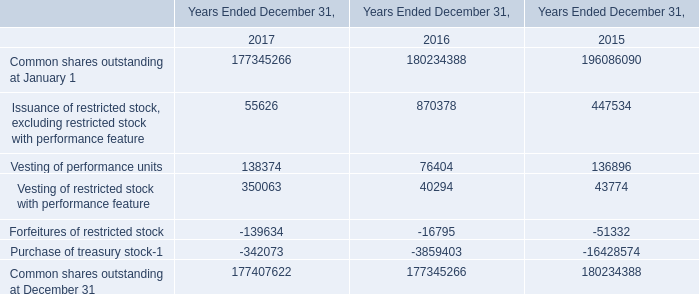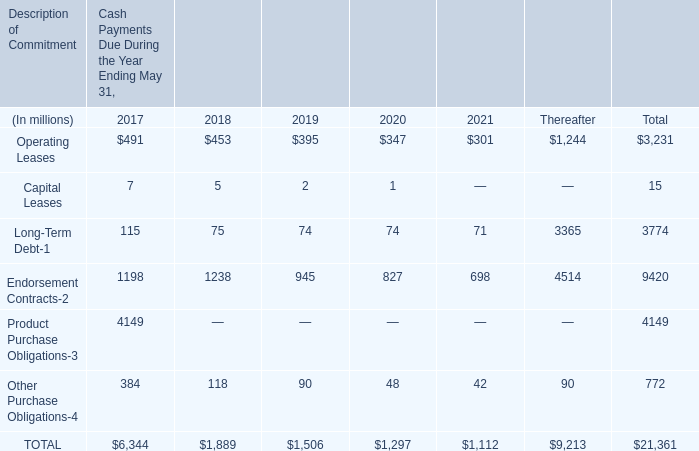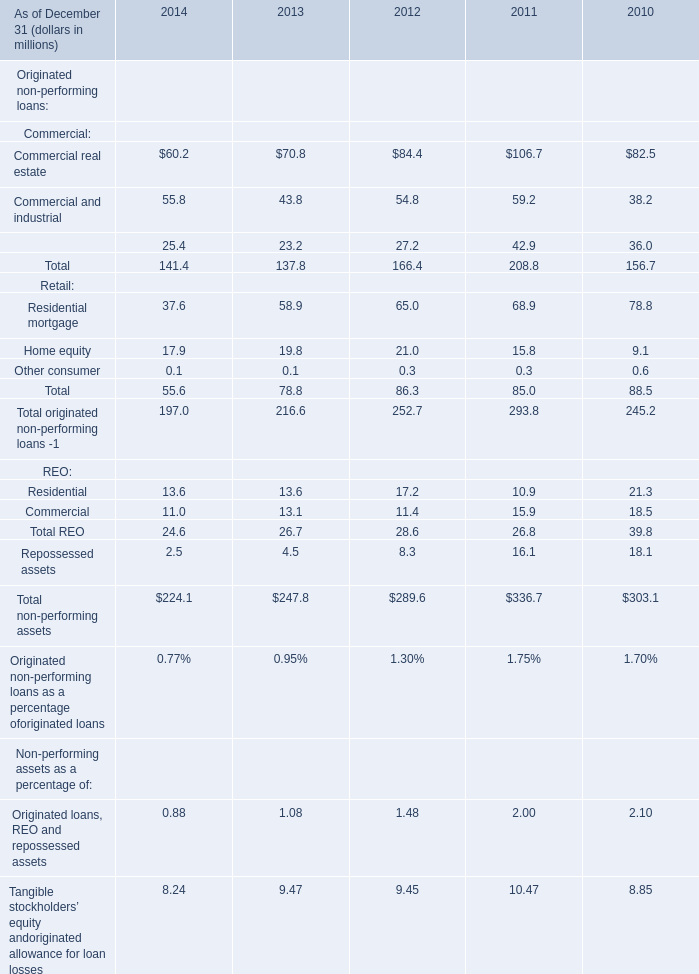What was the total amount of Commercial real estate and Commercial and industrial in 2014? (in million) 
Computations: (60.2 + 55.8)
Answer: 116.0. 